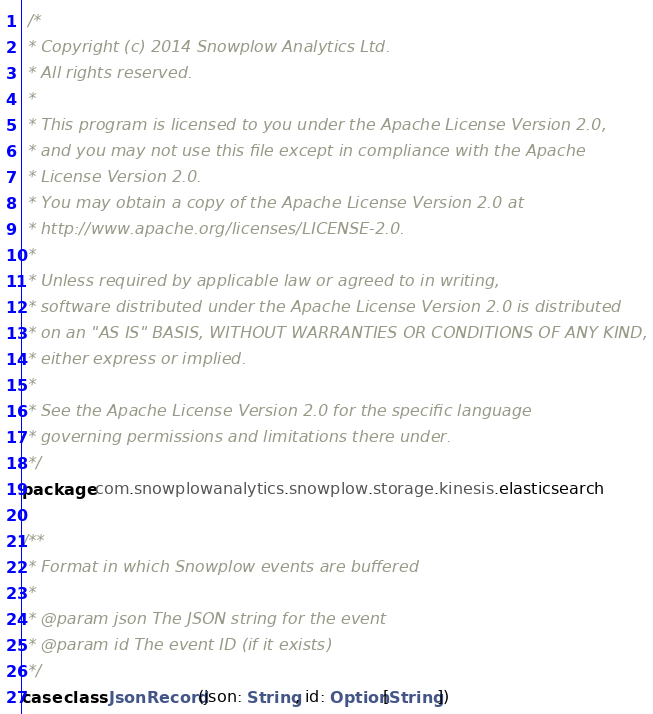Convert code to text. <code><loc_0><loc_0><loc_500><loc_500><_Scala_> /*
 * Copyright (c) 2014 Snowplow Analytics Ltd.
 * All rights reserved.
 *
 * This program is licensed to you under the Apache License Version 2.0,
 * and you may not use this file except in compliance with the Apache
 * License Version 2.0.
 * You may obtain a copy of the Apache License Version 2.0 at
 * http://www.apache.org/licenses/LICENSE-2.0.
 *
 * Unless required by applicable law or agreed to in writing,
 * software distributed under the Apache License Version 2.0 is distributed
 * on an "AS IS" BASIS, WITHOUT WARRANTIES OR CONDITIONS OF ANY KIND,
 * either express or implied.
 *
 * See the Apache License Version 2.0 for the specific language
 * governing permissions and limitations there under.
 */
package com.snowplowanalytics.snowplow.storage.kinesis.elasticsearch

/**
 * Format in which Snowplow events are buffered
 *
 * @param json The JSON string for the event
 * @param id The event ID (if it exists)
 */
case class JsonRecord(json: String, id: Option[String])
</code> 